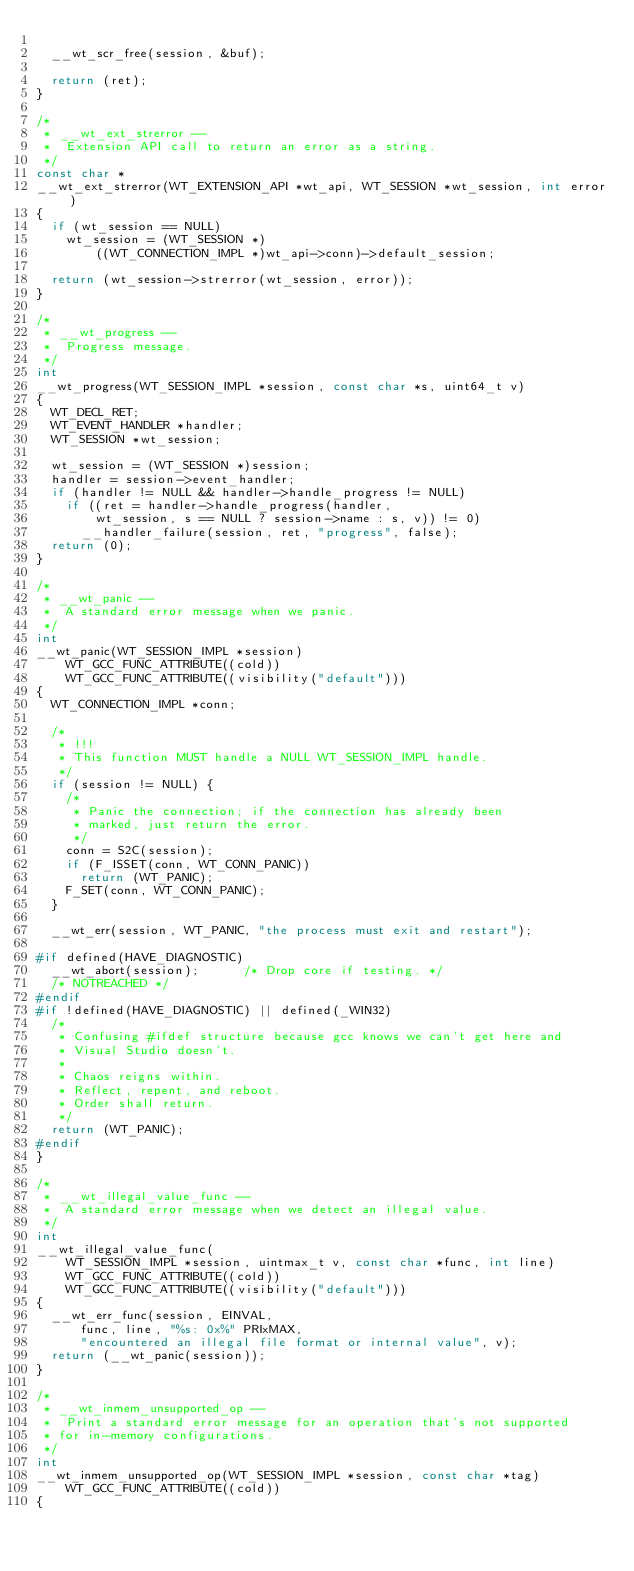<code> <loc_0><loc_0><loc_500><loc_500><_C_>
	__wt_scr_free(session, &buf);

	return (ret);
}

/*
 * __wt_ext_strerror --
 *	Extension API call to return an error as a string.
 */
const char *
__wt_ext_strerror(WT_EXTENSION_API *wt_api, WT_SESSION *wt_session, int error)
{
	if (wt_session == NULL)
		wt_session = (WT_SESSION *)
		    ((WT_CONNECTION_IMPL *)wt_api->conn)->default_session;

	return (wt_session->strerror(wt_session, error));
}

/*
 * __wt_progress --
 *	Progress message.
 */
int
__wt_progress(WT_SESSION_IMPL *session, const char *s, uint64_t v)
{
	WT_DECL_RET;
	WT_EVENT_HANDLER *handler;
	WT_SESSION *wt_session;

	wt_session = (WT_SESSION *)session;
	handler = session->event_handler;
	if (handler != NULL && handler->handle_progress != NULL)
		if ((ret = handler->handle_progress(handler,
		    wt_session, s == NULL ? session->name : s, v)) != 0)
			__handler_failure(session, ret, "progress", false);
	return (0);
}

/*
 * __wt_panic --
 *	A standard error message when we panic.
 */
int
__wt_panic(WT_SESSION_IMPL *session)
    WT_GCC_FUNC_ATTRIBUTE((cold))
    WT_GCC_FUNC_ATTRIBUTE((visibility("default")))
{
	WT_CONNECTION_IMPL *conn;

	/*
	 * !!!
	 * This function MUST handle a NULL WT_SESSION_IMPL handle.
	 */
	if (session != NULL) {
		/*
		 * Panic the connection; if the connection has already been
		 * marked, just return the error.
		 */
		conn = S2C(session);
		if (F_ISSET(conn, WT_CONN_PANIC))
			return (WT_PANIC);
		F_SET(conn, WT_CONN_PANIC);
	}

	__wt_err(session, WT_PANIC, "the process must exit and restart");

#if defined(HAVE_DIAGNOSTIC)
	__wt_abort(session);			/* Drop core if testing. */
	/* NOTREACHED */
#endif
#if !defined(HAVE_DIAGNOSTIC) || defined(_WIN32)
	/*
	 * Confusing #ifdef structure because gcc knows we can't get here and
	 * Visual Studio doesn't.
	 *
	 * Chaos reigns within.
	 * Reflect, repent, and reboot.
	 * Order shall return.
	 */
	return (WT_PANIC);
#endif
}

/*
 * __wt_illegal_value_func --
 *	A standard error message when we detect an illegal value.
 */
int
__wt_illegal_value_func(
    WT_SESSION_IMPL *session, uintmax_t v, const char *func, int line)
    WT_GCC_FUNC_ATTRIBUTE((cold))
    WT_GCC_FUNC_ATTRIBUTE((visibility("default")))
{
	__wt_err_func(session, EINVAL,
	    func, line, "%s: 0x%" PRIxMAX,
	    "encountered an illegal file format or internal value", v);
	return (__wt_panic(session));
}

/*
 * __wt_inmem_unsupported_op --
 *	Print a standard error message for an operation that's not supported
 * for in-memory configurations.
 */
int
__wt_inmem_unsupported_op(WT_SESSION_IMPL *session, const char *tag)
    WT_GCC_FUNC_ATTRIBUTE((cold))
{</code> 